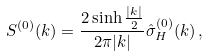Convert formula to latex. <formula><loc_0><loc_0><loc_500><loc_500>S ^ { ( 0 ) } ( k ) = \frac { 2 \sinh \frac { | k | } { 2 } } { 2 \pi | k | } \hat { \sigma } _ { H } ^ { ( 0 ) } ( k ) \, ,</formula> 